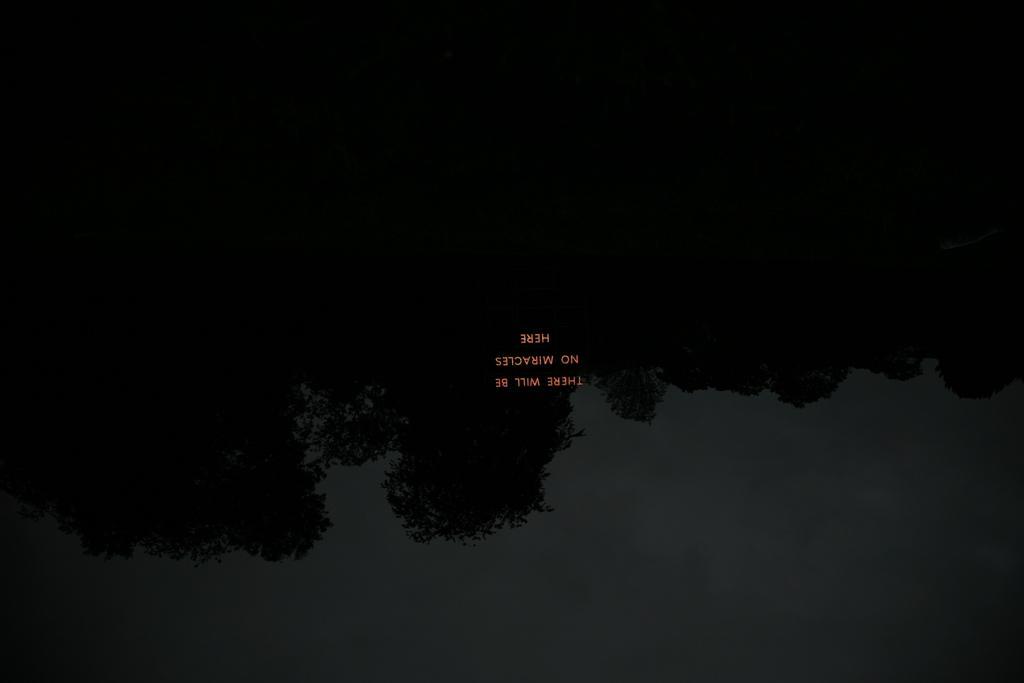Could you give a brief overview of what you see in this image? In this picture we can see there are trees and the sky. On the image, it is written something. 